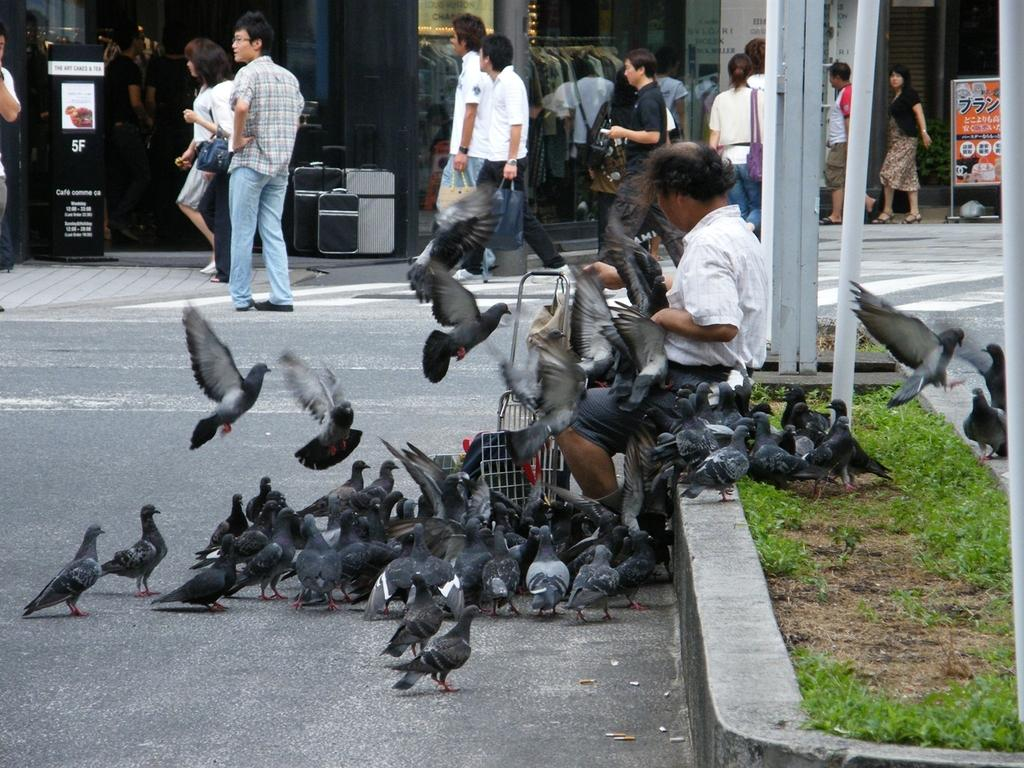What type of animals can be seen in the image? There are birds in the image. What type of vegetation is present in the image? There is grass in the image. What structures can be seen in the image? There are poles and boards in the image. What objects are carried by the persons in the image? There are bags in the image. What can be seen in the background of the image? In the background, there are glasses, clothes, and a pillar. What type of soap is being used to clean the furniture in the image? There is no furniture or soap present in the image. What order are the persons following in the image? There is no specific order or sequence of actions being followed by the persons in the image. 